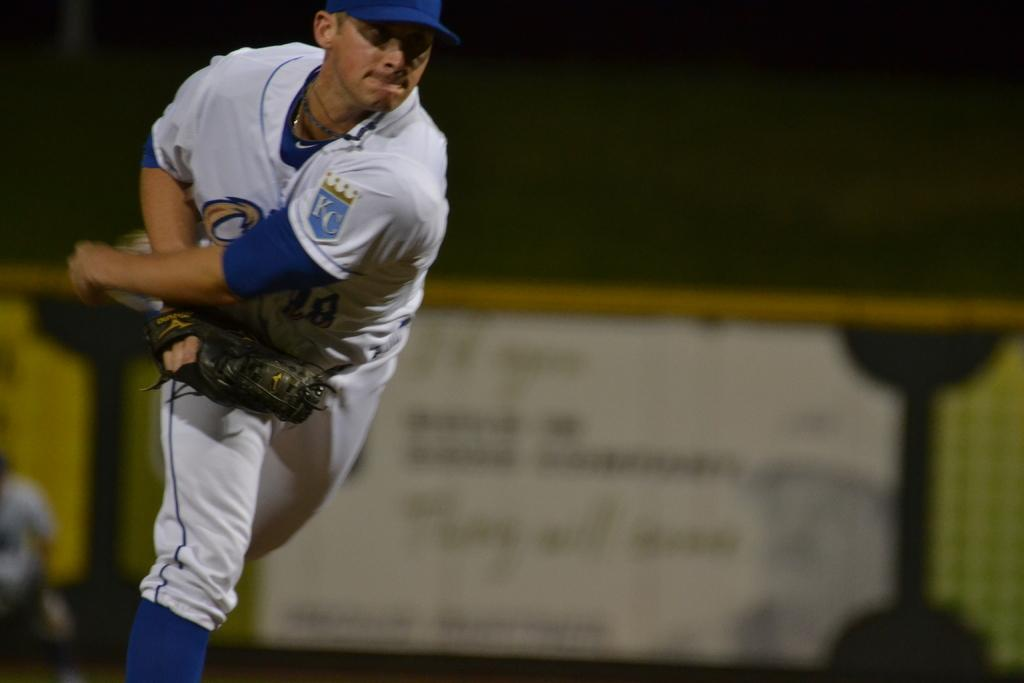<image>
Describe the image concisely. a man has the letters KC on his jerseys 